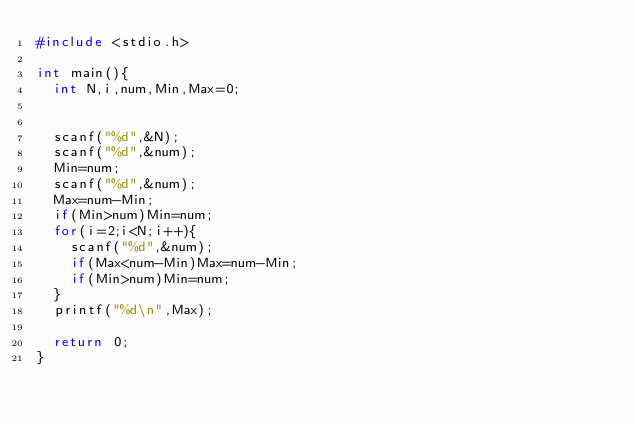<code> <loc_0><loc_0><loc_500><loc_500><_C_>#include <stdio.h>

int main(){
  int N,i,num,Min,Max=0;


  scanf("%d",&N);
  scanf("%d",&num);
  Min=num;
  scanf("%d",&num);
  Max=num-Min;
  if(Min>num)Min=num;
  for(i=2;i<N;i++){
    scanf("%d",&num);
    if(Max<num-Min)Max=num-Min;
    if(Min>num)Min=num;
  }
  printf("%d\n",Max);
  
  return 0;
}</code> 